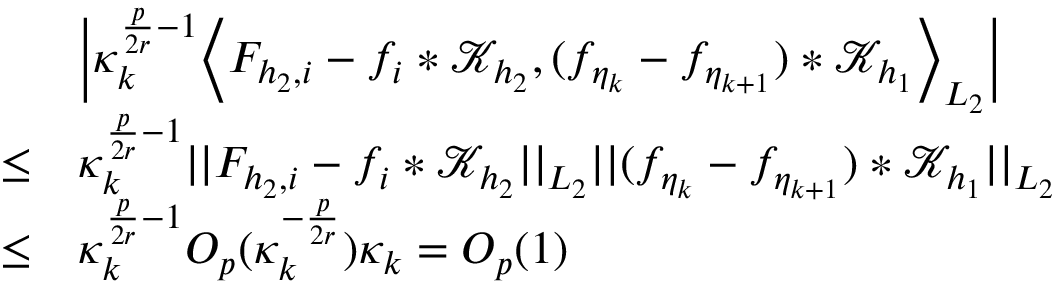Convert formula to latex. <formula><loc_0><loc_0><loc_500><loc_500>\begin{array} { r l } & { \left | \kappa _ { k } ^ { \frac { p } { 2 r } - 1 } \left \langle F _ { { h _ { 2 } } , i } - f _ { i } * \mathcal { K } _ { h _ { 2 } } , ( f _ { \eta _ { k } } - f _ { \eta _ { k + 1 } } ) * \mathcal { K } _ { h _ { 1 } } \right \rangle _ { L _ { 2 } } \right | } \\ { \leq } & { \kappa _ { k } ^ { \frac { p } { 2 r } - 1 } | | F _ { { h _ { 2 } } , i } - f _ { i } * \mathcal { K } _ { h _ { 2 } } | | _ { L _ { 2 } } | | ( f _ { \eta _ { k } } - f _ { \eta _ { k + 1 } } ) * \mathcal { K } _ { h _ { 1 } } | | _ { L _ { 2 } } } \\ { \leq } & { \kappa _ { k } ^ { \frac { p } { 2 r } - 1 } O _ { p } ( \kappa _ { k } ^ { - \frac { p } { 2 r } } ) \kappa _ { k } = O _ { p } ( 1 ) } \end{array}</formula> 